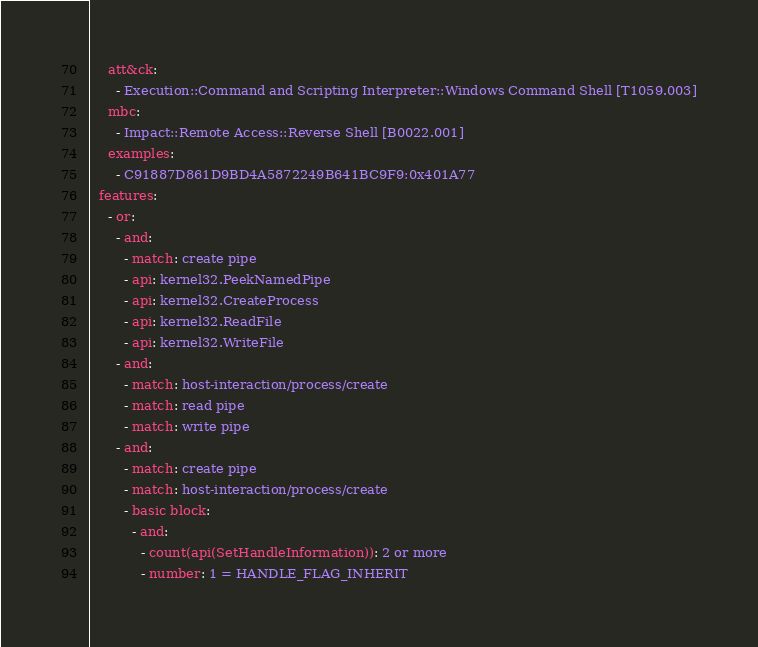<code> <loc_0><loc_0><loc_500><loc_500><_YAML_>    att&ck:
      - Execution::Command and Scripting Interpreter::Windows Command Shell [T1059.003]
    mbc:
      - Impact::Remote Access::Reverse Shell [B0022.001]
    examples:
      - C91887D861D9BD4A5872249B641BC9F9:0x401A77
  features:
    - or:
      - and:
        - match: create pipe
        - api: kernel32.PeekNamedPipe
        - api: kernel32.CreateProcess
        - api: kernel32.ReadFile
        - api: kernel32.WriteFile
      - and:
        - match: host-interaction/process/create
        - match: read pipe
        - match: write pipe
      - and:
        - match: create pipe
        - match: host-interaction/process/create
        - basic block:
          - and:
            - count(api(SetHandleInformation)): 2 or more
            - number: 1 = HANDLE_FLAG_INHERIT
</code> 